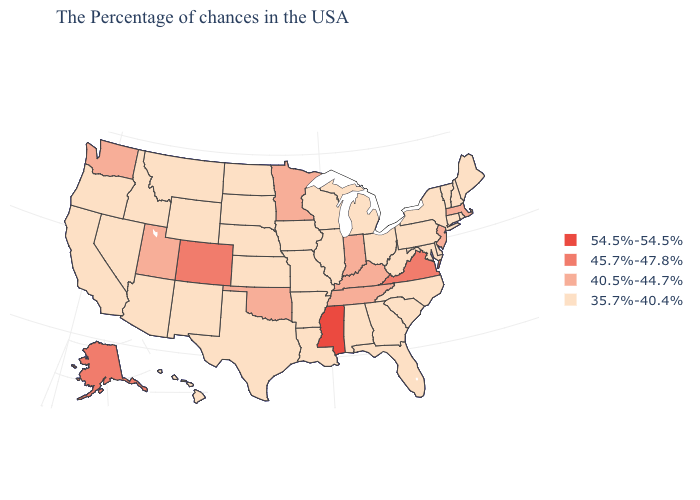Which states have the highest value in the USA?
Be succinct. Mississippi. How many symbols are there in the legend?
Give a very brief answer. 4. Which states have the highest value in the USA?
Answer briefly. Mississippi. Does Mississippi have the highest value in the USA?
Answer briefly. Yes. What is the lowest value in the USA?
Short answer required. 35.7%-40.4%. Does Illinois have the highest value in the USA?
Quick response, please. No. Among the states that border Ohio , does Kentucky have the highest value?
Write a very short answer. Yes. What is the value of New Mexico?
Answer briefly. 35.7%-40.4%. Which states have the lowest value in the Northeast?
Answer briefly. Maine, Rhode Island, New Hampshire, Vermont, Connecticut, New York, Pennsylvania. What is the lowest value in the MidWest?
Answer briefly. 35.7%-40.4%. Does New Jersey have the lowest value in the Northeast?
Quick response, please. No. Does Maine have a lower value than Indiana?
Give a very brief answer. Yes. Among the states that border North Carolina , which have the lowest value?
Short answer required. South Carolina, Georgia. What is the lowest value in the USA?
Give a very brief answer. 35.7%-40.4%. 